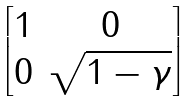Convert formula to latex. <formula><loc_0><loc_0><loc_500><loc_500>\begin{bmatrix} 1 & 0 \\ 0 & \sqrt { 1 - \gamma } \end{bmatrix}</formula> 